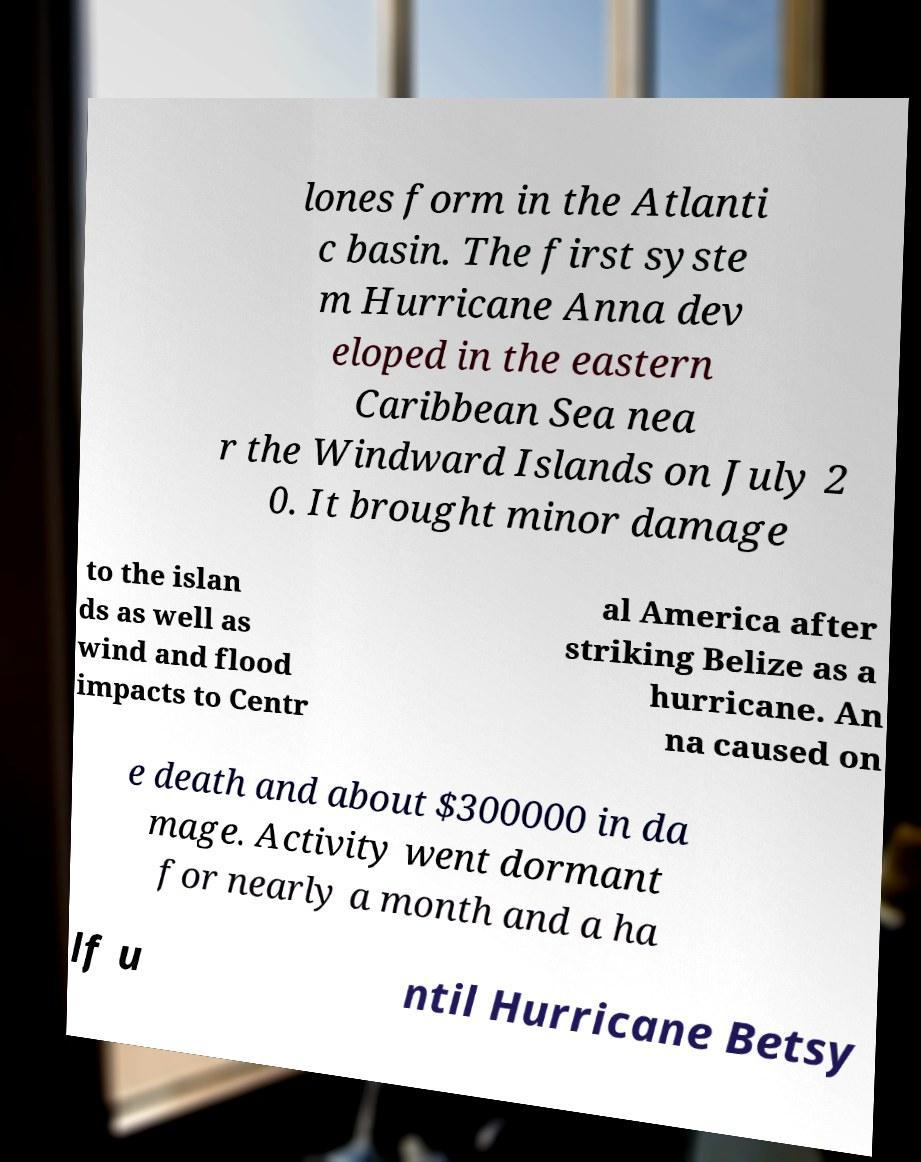Could you extract and type out the text from this image? lones form in the Atlanti c basin. The first syste m Hurricane Anna dev eloped in the eastern Caribbean Sea nea r the Windward Islands on July 2 0. It brought minor damage to the islan ds as well as wind and flood impacts to Centr al America after striking Belize as a hurricane. An na caused on e death and about $300000 in da mage. Activity went dormant for nearly a month and a ha lf u ntil Hurricane Betsy 